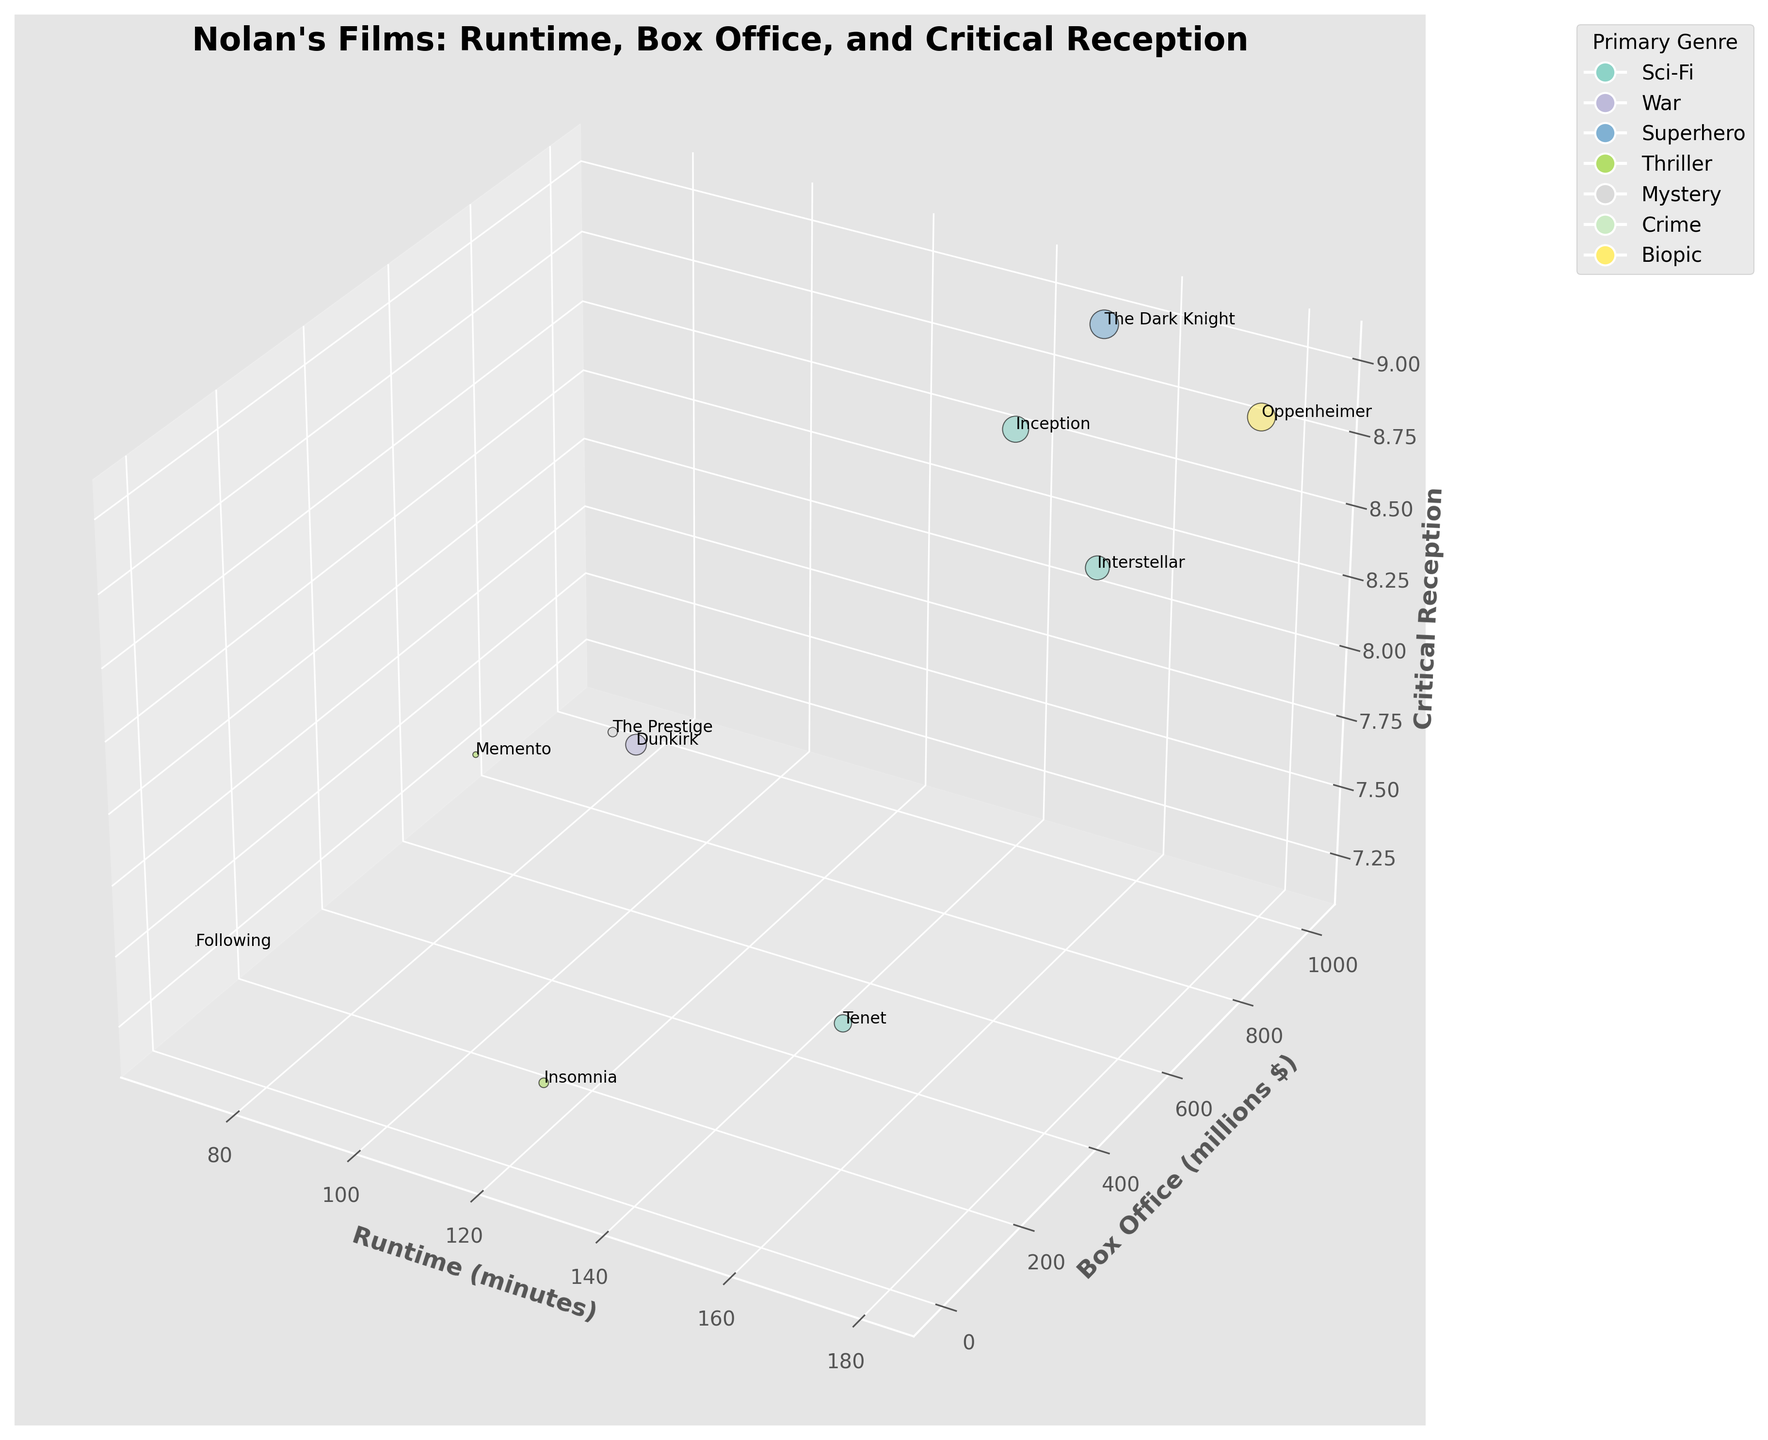How many films have a runtime of over 150 minutes? By looking along the x-axis, we can identify the films that are plotted above the 150-minute mark: "Interstellar," "The Dark Knight," "Inception," "Tenet," and "Oppenheimer."
Answer: 5 Which film has the highest box office revenue? On the y-axis, the film that reaches the highest value corresponds to the "The Dark Knight" at approximately 1005 million dollars.
Answer: The Dark Knight Which film falls under the theme "Sci-Fi/Space," and what is its runtime? By identifying the theme "Sci-Fi/Space," we see "Interstellar." Its position on the x-axis indicates a runtime of around 169 minutes.
Answer: Interstellar, 169 minutes How does the critical reception of "Dunkirk" compare to "Tenet"? "Dunkirk" has a critical reception value on the z-axis at approximately 7.8, while "Tenet" is around 7.3. Therefore, "Dunkirk" has a higher critical reception compared to "Tenet."
Answer: Dunkirk has a higher critical reception than Tenet What is the average box office revenue of films with a runtime less than 120 minutes? Identifying films with runtime less than 120 minutes: "Dunkirk" (527 million), "Memento" (40 million), "Following" (0.24 million), and "Insomnia" (113 million). Calculating average: (527 + 40 + 0.24 + 113) / 4 = 170 million.
Answer: 170 million dollars Which films are represented with the smallest bubble sizes on the chart? Smallest bubble sizes correlate with the smallest box office revenues, which are "Following" and "Memento."
Answer: Following and Memento Are there any films with the same primary genre but different themes? If so, which ones? By examining films with the same color, indicating the same primary genre: "Inception" (Sci-Fi/Heist), "Interstellar" (Sci-Fi/Space), and "Tenet" (Sci-Fi/Action) share Sci-Fi as the primary genre but have different sub-themes.
Answer: Inception, Interstellar, Tenet Which film has the longest runtime and its corresponding box office revenue and critical reception? The film with the longest runtime on the x-axis is "Oppenheimer" at 180 minutes. Its box office revenue is about 950 million dollars, and its critical reception value is approximately 8.9.
Answer: Oppenheimer, 950 million dollars, 8.9 What is the difference in box office revenue between "Inception" and "Insomnia"? "Inception" has a box office revenue of approximately 836 million dollars, while "Insomnia" has about 113 million dollars. Calculating the difference: 836 - 113 = 723 million dollars.
Answer: 723 million dollars How does the critical reception of "Memento" compare with "The Prestige"? "Memento" has a critical reception value of about 8.4, while "The Prestige" is about 8.5. Comparing these values, "The Prestige" has a marginally higher critical reception.
Answer: The Prestige has a slightly higher critical reception than Memento 